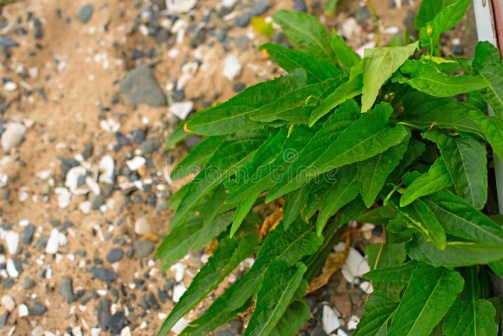Imagine a story where this plant is the main character. What kind of adventure might it have? Once upon a time, in a rugged, rocky terrain, there was a resilient plant named Verdantia. Verdantia was not just any plant, but the guardian spirit of the hillside. Her mission was to maintain the balance between the rocks and soil, providing a sanctuary for smaller creatures and other flora around her. One day, a severe drought threatened to dry up the spring that kept Verdantia and the entire ecosystem alive. Summoning all her strength, Verdantia embarked on an adventure deep into the heart of the mountain, where it was said an ancient underground river flowed. Traversing through the roots of ancient trees, facing stone-guardians, and solving nature's riddles, Verdantia eventually found the river. With wisdom and courage, she redirected its flow back to her hillside, restoring life and vitality to the terrain. Her leaves, once a vibrant green, now shone with a mystical glow, symbolizing her journey and the life-saving water she had brought back. Verdantia became a legend, a symbol of resilience and guardian of nature's secrets. 